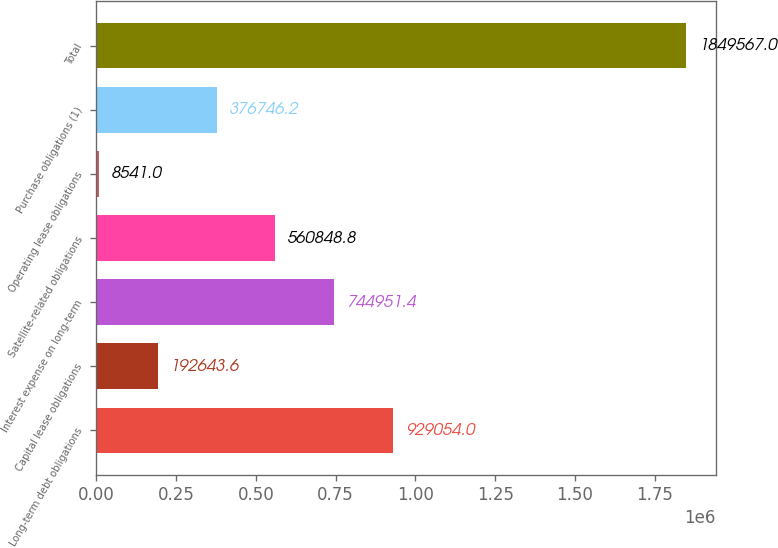Convert chart. <chart><loc_0><loc_0><loc_500><loc_500><bar_chart><fcel>Long-term debt obligations<fcel>Capital lease obligations<fcel>Interest expense on long-term<fcel>Satellite-related obligations<fcel>Operating lease obligations<fcel>Purchase obligations (1)<fcel>Total<nl><fcel>929054<fcel>192644<fcel>744951<fcel>560849<fcel>8541<fcel>376746<fcel>1.84957e+06<nl></chart> 